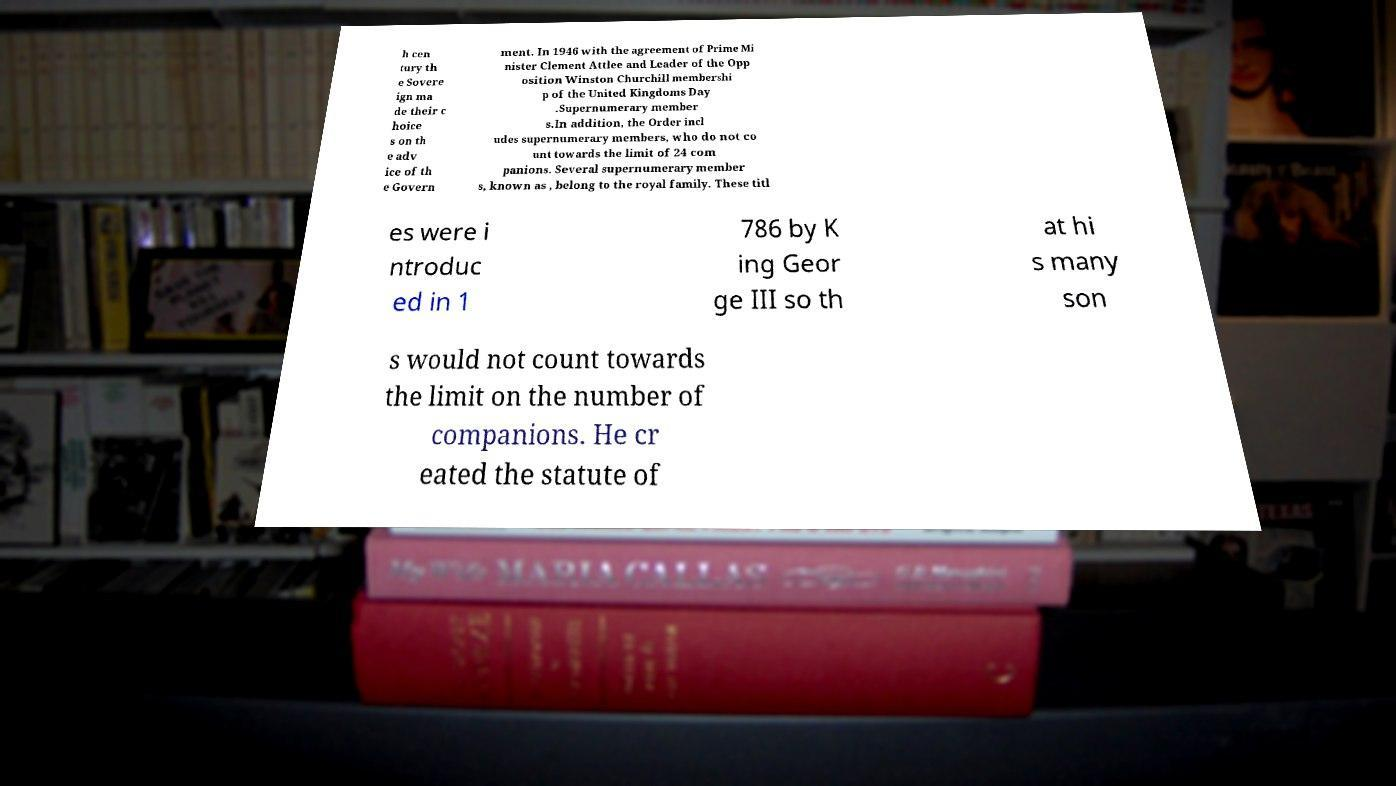There's text embedded in this image that I need extracted. Can you transcribe it verbatim? h cen tury th e Sovere ign ma de their c hoice s on th e adv ice of th e Govern ment. In 1946 with the agreement of Prime Mi nister Clement Attlee and Leader of the Opp osition Winston Churchill membershi p of the United Kingdoms Day .Supernumerary member s.In addition, the Order incl udes supernumerary members, who do not co unt towards the limit of 24 com panions. Several supernumerary member s, known as , belong to the royal family. These titl es were i ntroduc ed in 1 786 by K ing Geor ge III so th at hi s many son s would not count towards the limit on the number of companions. He cr eated the statute of 